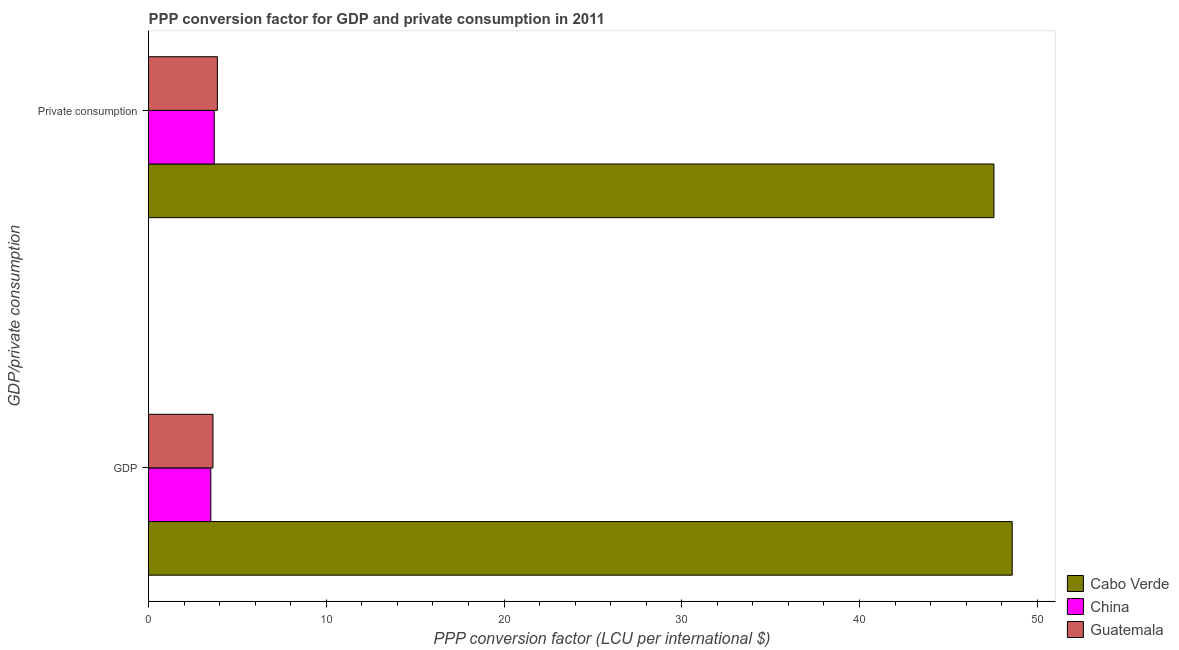How many groups of bars are there?
Your answer should be very brief. 2. Are the number of bars per tick equal to the number of legend labels?
Keep it short and to the point. Yes. How many bars are there on the 1st tick from the top?
Provide a short and direct response. 3. What is the label of the 2nd group of bars from the top?
Offer a terse response. GDP. What is the ppp conversion factor for private consumption in Cabo Verde?
Make the answer very short. 47.57. Across all countries, what is the maximum ppp conversion factor for private consumption?
Your answer should be compact. 47.57. Across all countries, what is the minimum ppp conversion factor for private consumption?
Keep it short and to the point. 3.7. In which country was the ppp conversion factor for gdp maximum?
Keep it short and to the point. Cabo Verde. In which country was the ppp conversion factor for private consumption minimum?
Keep it short and to the point. China. What is the total ppp conversion factor for gdp in the graph?
Offer a terse response. 55.72. What is the difference between the ppp conversion factor for gdp in Cabo Verde and that in China?
Offer a very short reply. 45.09. What is the difference between the ppp conversion factor for private consumption in Guatemala and the ppp conversion factor for gdp in China?
Your answer should be very brief. 0.37. What is the average ppp conversion factor for gdp per country?
Keep it short and to the point. 18.57. What is the difference between the ppp conversion factor for private consumption and ppp conversion factor for gdp in China?
Provide a succinct answer. 0.19. What is the ratio of the ppp conversion factor for private consumption in Guatemala to that in China?
Provide a short and direct response. 1.05. What does the 1st bar from the top in GDP represents?
Your response must be concise. Guatemala. What does the 3rd bar from the bottom in GDP represents?
Ensure brevity in your answer.  Guatemala. How many bars are there?
Provide a succinct answer. 6. Are all the bars in the graph horizontal?
Your response must be concise. Yes. Does the graph contain any zero values?
Ensure brevity in your answer.  No. Does the graph contain grids?
Your response must be concise. No. Where does the legend appear in the graph?
Give a very brief answer. Bottom right. How are the legend labels stacked?
Ensure brevity in your answer.  Vertical. What is the title of the graph?
Keep it short and to the point. PPP conversion factor for GDP and private consumption in 2011. Does "Mauritania" appear as one of the legend labels in the graph?
Offer a very short reply. No. What is the label or title of the X-axis?
Provide a succinct answer. PPP conversion factor (LCU per international $). What is the label or title of the Y-axis?
Ensure brevity in your answer.  GDP/private consumption. What is the PPP conversion factor (LCU per international $) of Cabo Verde in GDP?
Provide a succinct answer. 48.59. What is the PPP conversion factor (LCU per international $) in China in GDP?
Your answer should be very brief. 3.51. What is the PPP conversion factor (LCU per international $) in Guatemala in GDP?
Your answer should be compact. 3.63. What is the PPP conversion factor (LCU per international $) of Cabo Verde in  Private consumption?
Offer a very short reply. 47.57. What is the PPP conversion factor (LCU per international $) in China in  Private consumption?
Give a very brief answer. 3.7. What is the PPP conversion factor (LCU per international $) in Guatemala in  Private consumption?
Offer a terse response. 3.87. Across all GDP/private consumption, what is the maximum PPP conversion factor (LCU per international $) of Cabo Verde?
Offer a terse response. 48.59. Across all GDP/private consumption, what is the maximum PPP conversion factor (LCU per international $) of China?
Ensure brevity in your answer.  3.7. Across all GDP/private consumption, what is the maximum PPP conversion factor (LCU per international $) of Guatemala?
Your response must be concise. 3.87. Across all GDP/private consumption, what is the minimum PPP conversion factor (LCU per international $) in Cabo Verde?
Offer a very short reply. 47.57. Across all GDP/private consumption, what is the minimum PPP conversion factor (LCU per international $) in China?
Ensure brevity in your answer.  3.51. Across all GDP/private consumption, what is the minimum PPP conversion factor (LCU per international $) of Guatemala?
Give a very brief answer. 3.63. What is the total PPP conversion factor (LCU per international $) of Cabo Verde in the graph?
Your response must be concise. 96.16. What is the total PPP conversion factor (LCU per international $) in China in the graph?
Ensure brevity in your answer.  7.2. What is the total PPP conversion factor (LCU per international $) in Guatemala in the graph?
Keep it short and to the point. 7.5. What is the difference between the PPP conversion factor (LCU per international $) of Cabo Verde in GDP and that in  Private consumption?
Provide a succinct answer. 1.03. What is the difference between the PPP conversion factor (LCU per international $) in China in GDP and that in  Private consumption?
Your answer should be very brief. -0.19. What is the difference between the PPP conversion factor (LCU per international $) in Guatemala in GDP and that in  Private consumption?
Keep it short and to the point. -0.25. What is the difference between the PPP conversion factor (LCU per international $) of Cabo Verde in GDP and the PPP conversion factor (LCU per international $) of China in  Private consumption?
Make the answer very short. 44.9. What is the difference between the PPP conversion factor (LCU per international $) in Cabo Verde in GDP and the PPP conversion factor (LCU per international $) in Guatemala in  Private consumption?
Your response must be concise. 44.72. What is the difference between the PPP conversion factor (LCU per international $) in China in GDP and the PPP conversion factor (LCU per international $) in Guatemala in  Private consumption?
Give a very brief answer. -0.37. What is the average PPP conversion factor (LCU per international $) in Cabo Verde per GDP/private consumption?
Provide a short and direct response. 48.08. What is the average PPP conversion factor (LCU per international $) of China per GDP/private consumption?
Make the answer very short. 3.6. What is the average PPP conversion factor (LCU per international $) in Guatemala per GDP/private consumption?
Make the answer very short. 3.75. What is the difference between the PPP conversion factor (LCU per international $) in Cabo Verde and PPP conversion factor (LCU per international $) in China in GDP?
Offer a very short reply. 45.09. What is the difference between the PPP conversion factor (LCU per international $) of Cabo Verde and PPP conversion factor (LCU per international $) of Guatemala in GDP?
Keep it short and to the point. 44.97. What is the difference between the PPP conversion factor (LCU per international $) of China and PPP conversion factor (LCU per international $) of Guatemala in GDP?
Keep it short and to the point. -0.12. What is the difference between the PPP conversion factor (LCU per international $) of Cabo Verde and PPP conversion factor (LCU per international $) of China in  Private consumption?
Ensure brevity in your answer.  43.87. What is the difference between the PPP conversion factor (LCU per international $) in Cabo Verde and PPP conversion factor (LCU per international $) in Guatemala in  Private consumption?
Provide a succinct answer. 43.69. What is the difference between the PPP conversion factor (LCU per international $) of China and PPP conversion factor (LCU per international $) of Guatemala in  Private consumption?
Offer a very short reply. -0.18. What is the ratio of the PPP conversion factor (LCU per international $) of Cabo Verde in GDP to that in  Private consumption?
Your answer should be very brief. 1.02. What is the ratio of the PPP conversion factor (LCU per international $) in China in GDP to that in  Private consumption?
Ensure brevity in your answer.  0.95. What is the ratio of the PPP conversion factor (LCU per international $) of Guatemala in GDP to that in  Private consumption?
Keep it short and to the point. 0.94. What is the difference between the highest and the second highest PPP conversion factor (LCU per international $) of Cabo Verde?
Give a very brief answer. 1.03. What is the difference between the highest and the second highest PPP conversion factor (LCU per international $) in China?
Provide a short and direct response. 0.19. What is the difference between the highest and the second highest PPP conversion factor (LCU per international $) in Guatemala?
Ensure brevity in your answer.  0.25. What is the difference between the highest and the lowest PPP conversion factor (LCU per international $) in Cabo Verde?
Your response must be concise. 1.03. What is the difference between the highest and the lowest PPP conversion factor (LCU per international $) in China?
Offer a terse response. 0.19. What is the difference between the highest and the lowest PPP conversion factor (LCU per international $) in Guatemala?
Ensure brevity in your answer.  0.25. 